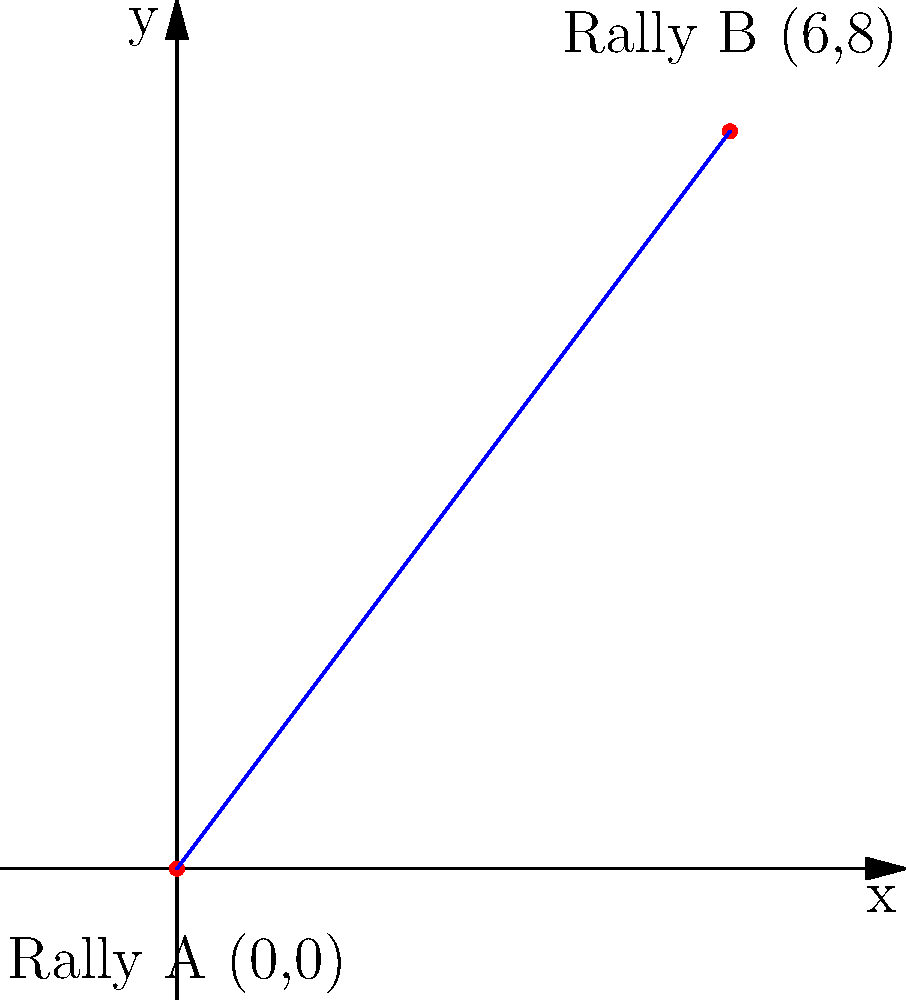Two major biker rallies are taking place in different cities. Rally A is located at coordinates (0,0) and Rally B is at (6,8) on a coordinate plane where each unit represents 10 miles. As a motorcycle enthusiast planning the most efficient route between these rallies, what is the shortest distance in miles between Rally A and Rally B? To find the shortest distance between two points on a coordinate plane, we can use the distance formula, which is derived from the Pythagorean theorem.

The distance formula is:
$$d = \sqrt{(x_2 - x_1)^2 + (y_2 - y_1)^2}$$

Where $(x_1, y_1)$ are the coordinates of the first point and $(x_2, y_2)$ are the coordinates of the second point.

Given:
Rally A: $(x_1, y_1) = (0, 0)$
Rally B: $(x_2, y_2) = (6, 8)$

Let's plug these values into the formula:

$$d = \sqrt{(6 - 0)^2 + (8 - 0)^2}$$
$$d = \sqrt{6^2 + 8^2}$$
$$d = \sqrt{36 + 64}$$
$$d = \sqrt{100}$$
$$d = 10$$

This gives us the distance in coordinate units. Since each unit represents 10 miles, we need to multiply our result by 10:

$10 \times 10 = 100$ miles

Therefore, the shortest distance between Rally A and Rally B is 100 miles.
Answer: 100 miles 